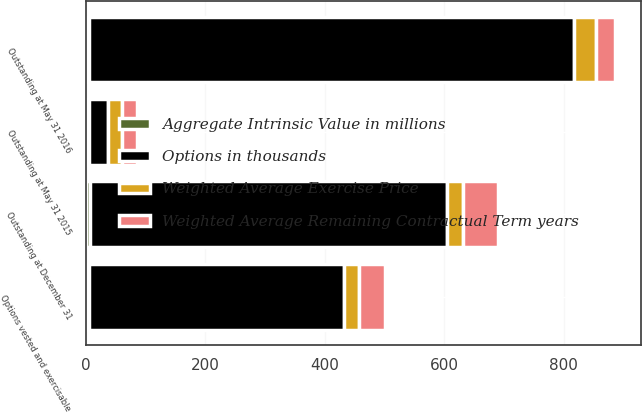<chart> <loc_0><loc_0><loc_500><loc_500><stacked_bar_chart><ecel><fcel>Outstanding at May 31 2015<fcel>Outstanding at May 31 2016<fcel>Outstanding at December 31<fcel>Options vested and exercisable<nl><fcel>Options in thousands<fcel>31.81<fcel>811<fcel>598<fcel>427<nl><fcel>Weighted Average Remaining Contractual Term years<fcel>25.47<fcel>31.81<fcel>59.16<fcel>44.34<nl><fcel>Aggregate Intrinsic Value in millions<fcel>5.2<fcel>5.8<fcel>6.2<fcel>5.2<nl><fcel>Weighted Average Exercise Price<fcel>23.9<fcel>36.8<fcel>27.3<fcel>25.1<nl></chart> 